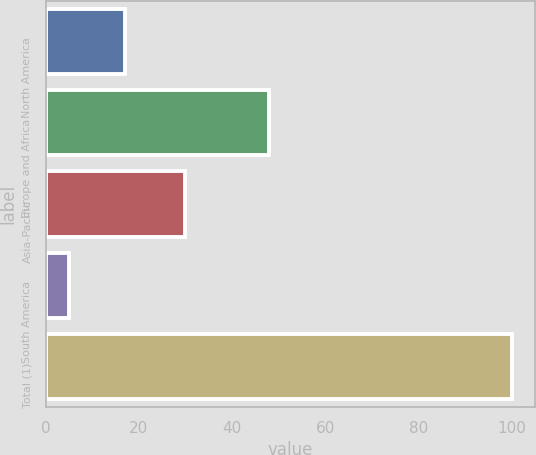<chart> <loc_0><loc_0><loc_500><loc_500><bar_chart><fcel>North America<fcel>Europe and Africa<fcel>Asia-Pacific<fcel>South America<fcel>Total (1)<nl><fcel>17<fcel>48<fcel>30<fcel>5<fcel>100<nl></chart> 